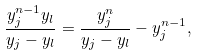<formula> <loc_0><loc_0><loc_500><loc_500>\frac { y _ { j } ^ { n - 1 } y _ { l } } { y _ { j } - y _ { l } } = \frac { y _ { j } ^ { n } } { y _ { j } - y _ { l } } - y _ { j } ^ { n - 1 } ,</formula> 